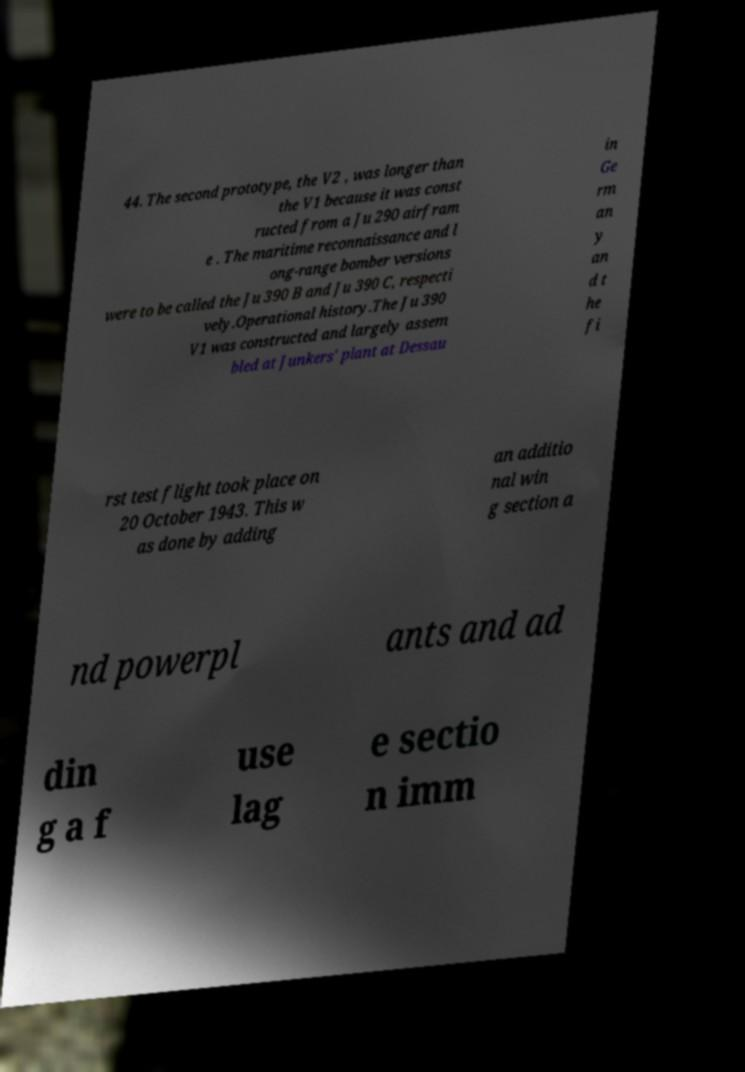Can you read and provide the text displayed in the image?This photo seems to have some interesting text. Can you extract and type it out for me? 44. The second prototype, the V2 , was longer than the V1 because it was const ructed from a Ju 290 airfram e . The maritime reconnaissance and l ong-range bomber versions were to be called the Ju 390 B and Ju 390 C, respecti vely.Operational history.The Ju 390 V1 was constructed and largely assem bled at Junkers' plant at Dessau in Ge rm an y an d t he fi rst test flight took place on 20 October 1943. This w as done by adding an additio nal win g section a nd powerpl ants and ad din g a f use lag e sectio n imm 